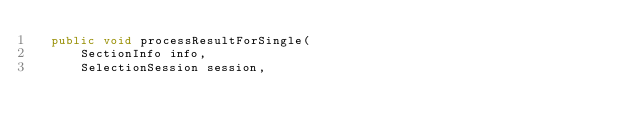Convert code to text. <code><loc_0><loc_0><loc_500><loc_500><_Java_>  public void processResultForSingle(
      SectionInfo info,
      SelectionSession session,</code> 